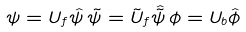<formula> <loc_0><loc_0><loc_500><loc_500>\psi = U _ { f } \hat { \psi } \, \tilde { \psi } = \tilde { U } _ { f } \hat { \tilde { \psi } } \, \phi = U _ { b } \hat { \phi }</formula> 